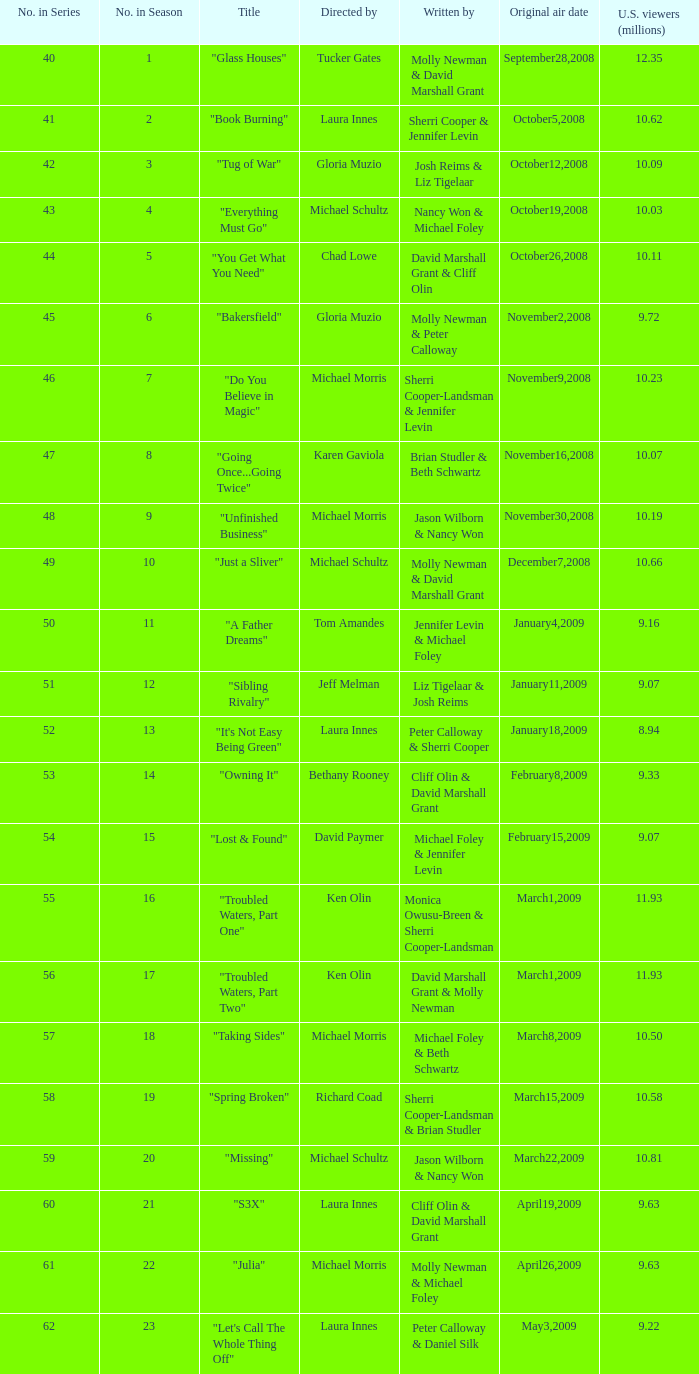What's the name of the episode seen by 9.63 millions of people in the US, whose director is Laura Innes? "S3X". 